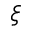<formula> <loc_0><loc_0><loc_500><loc_500>\xi</formula> 